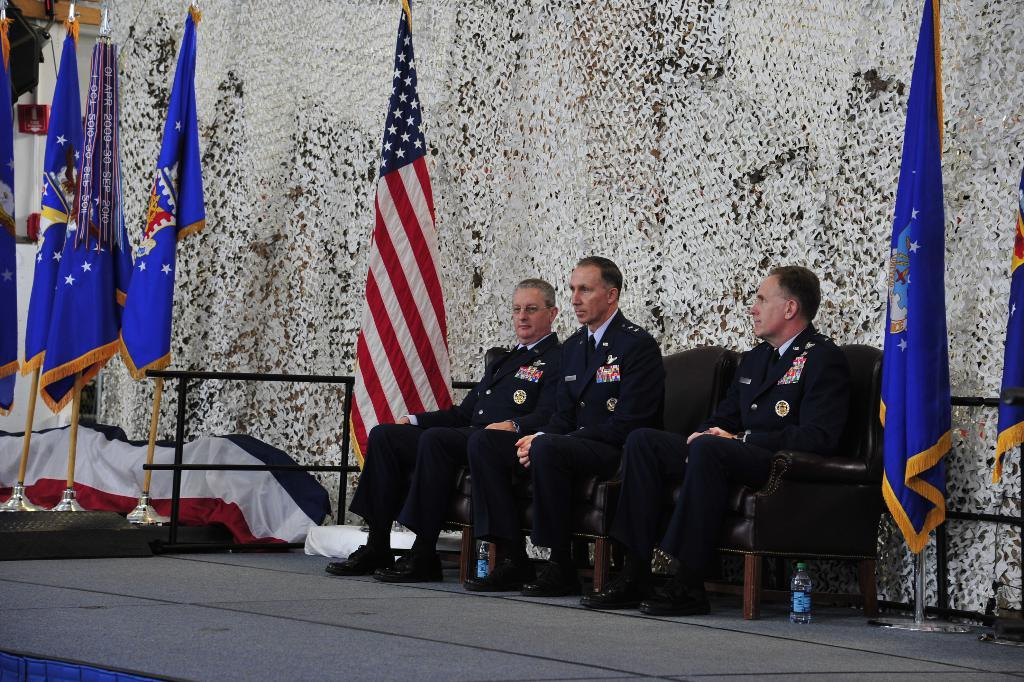How many people are in the image? There is a group of persons in the image. What are the persons doing in the image? The persons are sitting on chairs. What are the persons wearing in the image? The persons are wearing suits. What can be seen in the image besides the persons? There are flags in the image. What is the color of the background in the image? The background of the image is white. How does the group of persons care for the roll in the image? There is no roll present in the image, so the question cannot be answered. 